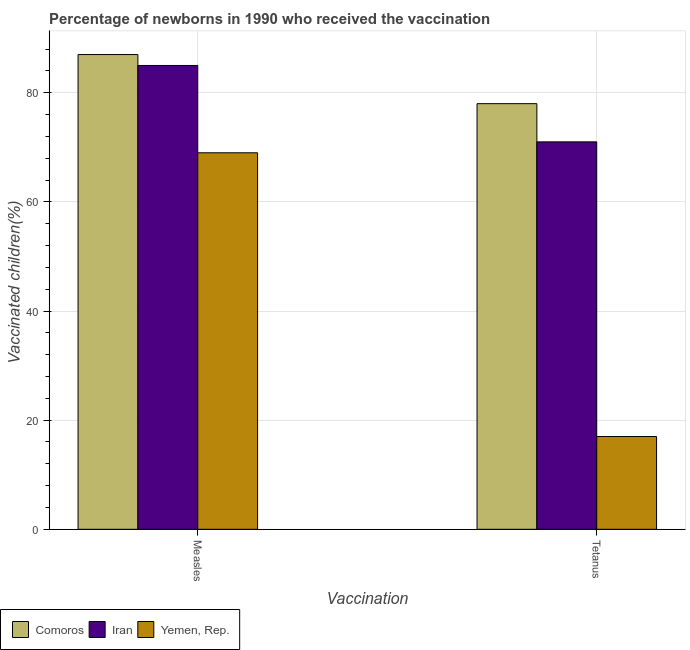How many different coloured bars are there?
Keep it short and to the point. 3. How many groups of bars are there?
Your answer should be very brief. 2. Are the number of bars per tick equal to the number of legend labels?
Your response must be concise. Yes. How many bars are there on the 1st tick from the left?
Your answer should be compact. 3. How many bars are there on the 2nd tick from the right?
Offer a very short reply. 3. What is the label of the 1st group of bars from the left?
Ensure brevity in your answer.  Measles. What is the percentage of newborns who received vaccination for measles in Iran?
Give a very brief answer. 85. Across all countries, what is the maximum percentage of newborns who received vaccination for measles?
Offer a very short reply. 87. Across all countries, what is the minimum percentage of newborns who received vaccination for measles?
Give a very brief answer. 69. In which country was the percentage of newborns who received vaccination for tetanus maximum?
Your answer should be compact. Comoros. In which country was the percentage of newborns who received vaccination for tetanus minimum?
Your answer should be compact. Yemen, Rep. What is the total percentage of newborns who received vaccination for measles in the graph?
Your answer should be very brief. 241. What is the difference between the percentage of newborns who received vaccination for measles in Comoros and that in Yemen, Rep.?
Give a very brief answer. 18. What is the difference between the percentage of newborns who received vaccination for measles in Comoros and the percentage of newborns who received vaccination for tetanus in Iran?
Make the answer very short. 16. What is the average percentage of newborns who received vaccination for measles per country?
Your answer should be very brief. 80.33. What is the difference between the percentage of newborns who received vaccination for tetanus and percentage of newborns who received vaccination for measles in Comoros?
Keep it short and to the point. -9. What is the ratio of the percentage of newborns who received vaccination for measles in Comoros to that in Yemen, Rep.?
Ensure brevity in your answer.  1.26. In how many countries, is the percentage of newborns who received vaccination for tetanus greater than the average percentage of newborns who received vaccination for tetanus taken over all countries?
Offer a terse response. 2. What does the 2nd bar from the left in Tetanus represents?
Your answer should be very brief. Iran. What does the 3rd bar from the right in Tetanus represents?
Keep it short and to the point. Comoros. Are all the bars in the graph horizontal?
Keep it short and to the point. No. What is the difference between two consecutive major ticks on the Y-axis?
Provide a succinct answer. 20. Does the graph contain any zero values?
Your answer should be compact. No. Where does the legend appear in the graph?
Your answer should be very brief. Bottom left. How many legend labels are there?
Your answer should be very brief. 3. What is the title of the graph?
Your answer should be compact. Percentage of newborns in 1990 who received the vaccination. Does "St. Vincent and the Grenadines" appear as one of the legend labels in the graph?
Keep it short and to the point. No. What is the label or title of the X-axis?
Make the answer very short. Vaccination. What is the label or title of the Y-axis?
Your answer should be compact. Vaccinated children(%)
. What is the Vaccinated children(%)
 of Comoros in Measles?
Offer a very short reply. 87. What is the Vaccinated children(%)
 in Iran in Measles?
Keep it short and to the point. 85. What is the Vaccinated children(%)
 of Comoros in Tetanus?
Ensure brevity in your answer.  78. What is the Vaccinated children(%)
 in Iran in Tetanus?
Ensure brevity in your answer.  71. What is the Vaccinated children(%)
 of Yemen, Rep. in Tetanus?
Your answer should be very brief. 17. Across all Vaccination, what is the maximum Vaccinated children(%)
 of Yemen, Rep.?
Provide a short and direct response. 69. Across all Vaccination, what is the minimum Vaccinated children(%)
 in Iran?
Provide a succinct answer. 71. What is the total Vaccinated children(%)
 in Comoros in the graph?
Your answer should be compact. 165. What is the total Vaccinated children(%)
 of Iran in the graph?
Provide a short and direct response. 156. What is the difference between the Vaccinated children(%)
 of Comoros in Measles and that in Tetanus?
Ensure brevity in your answer.  9. What is the difference between the Vaccinated children(%)
 in Iran in Measles and that in Tetanus?
Your answer should be compact. 14. What is the difference between the Vaccinated children(%)
 of Yemen, Rep. in Measles and that in Tetanus?
Offer a terse response. 52. What is the difference between the Vaccinated children(%)
 of Comoros in Measles and the Vaccinated children(%)
 of Iran in Tetanus?
Provide a succinct answer. 16. What is the difference between the Vaccinated children(%)
 in Iran in Measles and the Vaccinated children(%)
 in Yemen, Rep. in Tetanus?
Your answer should be very brief. 68. What is the average Vaccinated children(%)
 in Comoros per Vaccination?
Offer a terse response. 82.5. What is the average Vaccinated children(%)
 of Yemen, Rep. per Vaccination?
Offer a terse response. 43. What is the difference between the Vaccinated children(%)
 in Comoros and Vaccinated children(%)
 in Iran in Tetanus?
Ensure brevity in your answer.  7. What is the ratio of the Vaccinated children(%)
 in Comoros in Measles to that in Tetanus?
Your answer should be compact. 1.12. What is the ratio of the Vaccinated children(%)
 of Iran in Measles to that in Tetanus?
Your answer should be compact. 1.2. What is the ratio of the Vaccinated children(%)
 of Yemen, Rep. in Measles to that in Tetanus?
Ensure brevity in your answer.  4.06. What is the difference between the highest and the second highest Vaccinated children(%)
 of Comoros?
Make the answer very short. 9. What is the difference between the highest and the second highest Vaccinated children(%)
 of Iran?
Your response must be concise. 14. What is the difference between the highest and the second highest Vaccinated children(%)
 in Yemen, Rep.?
Offer a very short reply. 52. What is the difference between the highest and the lowest Vaccinated children(%)
 in Comoros?
Ensure brevity in your answer.  9. What is the difference between the highest and the lowest Vaccinated children(%)
 of Yemen, Rep.?
Make the answer very short. 52. 